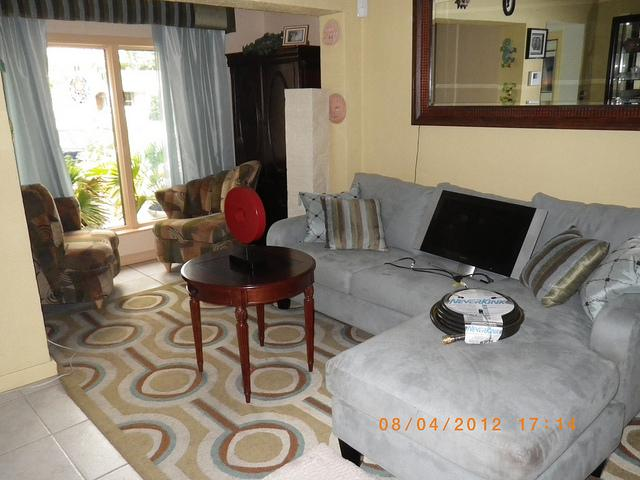What is on the couch? monitor 